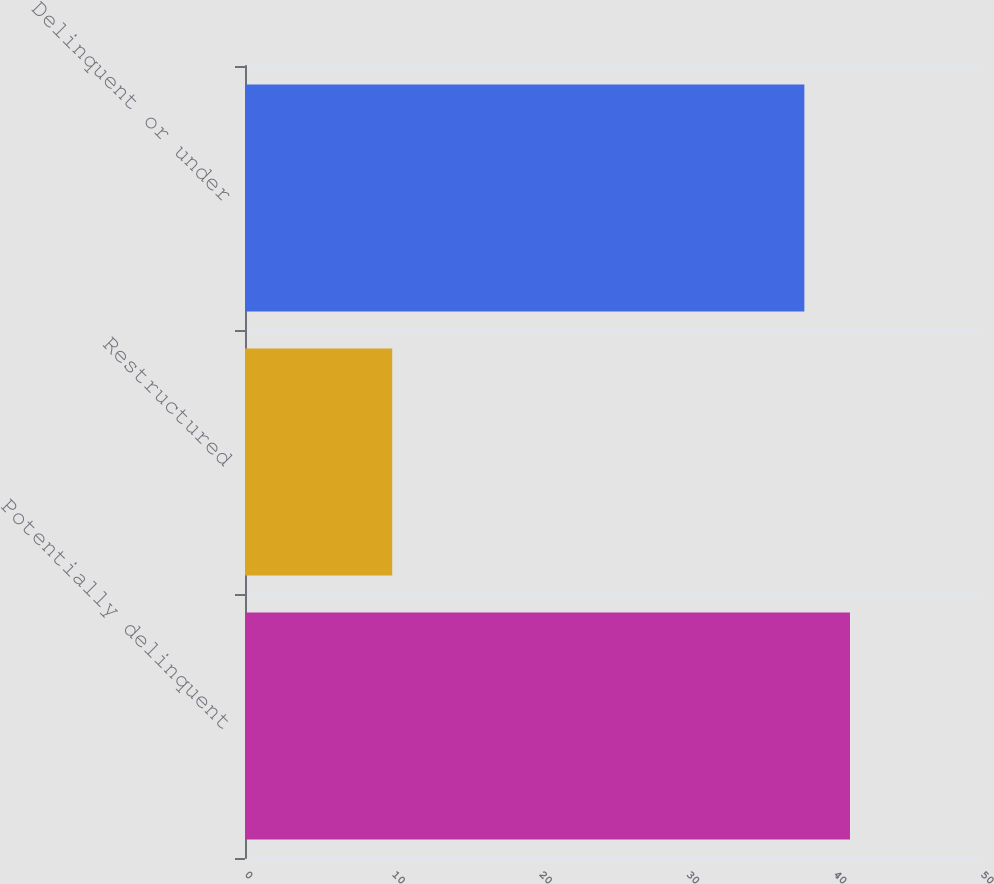<chart> <loc_0><loc_0><loc_500><loc_500><bar_chart><fcel>Potentially delinquent<fcel>Restructured<fcel>Delinquent or under<nl><fcel>41.1<fcel>10<fcel>38<nl></chart> 